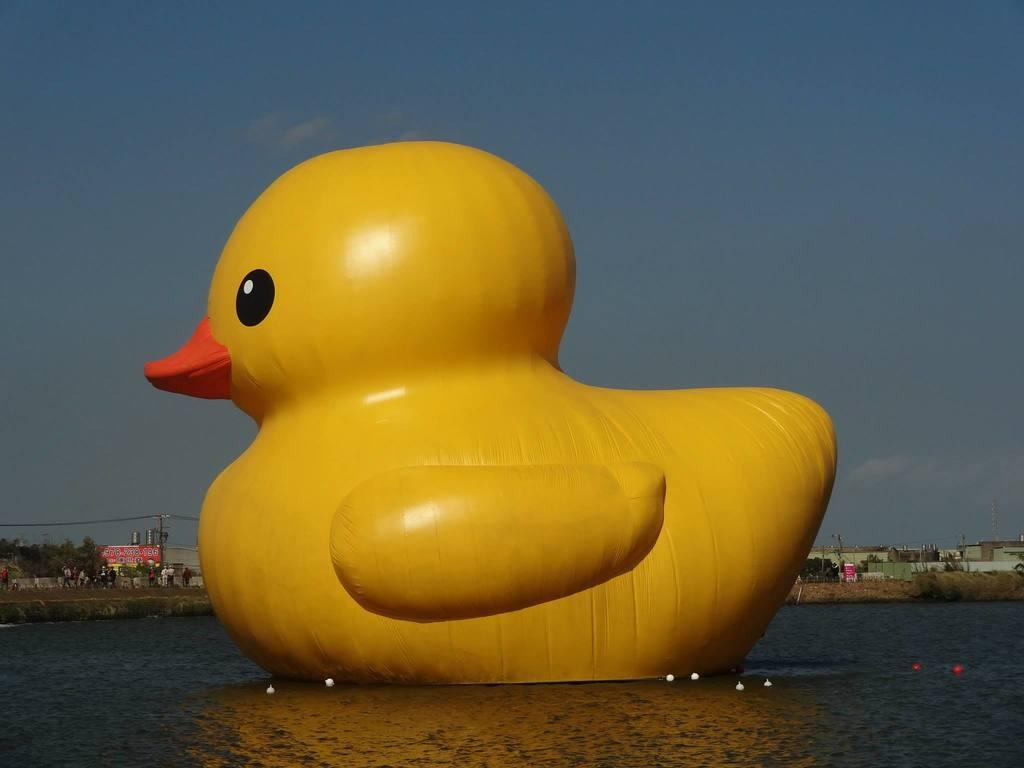What is the main subject of the image? There is a huge gas balloon of a duck in the image. What can be seen in the background of the image? There are buildings behind the gas balloon. What type of vegetation is present in the image? There are trees in the image. How would you describe the weather in the image? The sky is clear in the image, suggesting good weather. What type of drum can be heard playing in the image? There is no drum or sound present in the image; it is a still image of a gas balloon, buildings, and trees. 